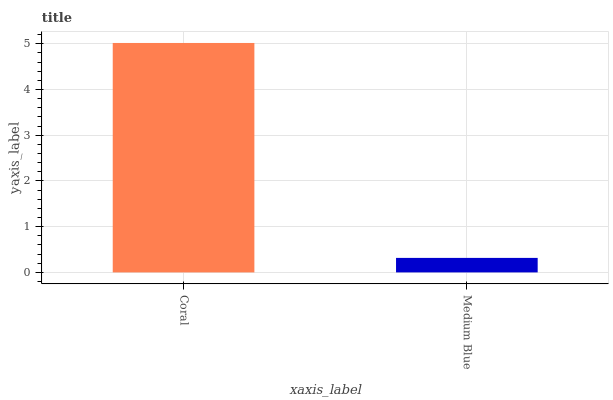Is Medium Blue the maximum?
Answer yes or no. No. Is Coral greater than Medium Blue?
Answer yes or no. Yes. Is Medium Blue less than Coral?
Answer yes or no. Yes. Is Medium Blue greater than Coral?
Answer yes or no. No. Is Coral less than Medium Blue?
Answer yes or no. No. Is Coral the high median?
Answer yes or no. Yes. Is Medium Blue the low median?
Answer yes or no. Yes. Is Medium Blue the high median?
Answer yes or no. No. Is Coral the low median?
Answer yes or no. No. 